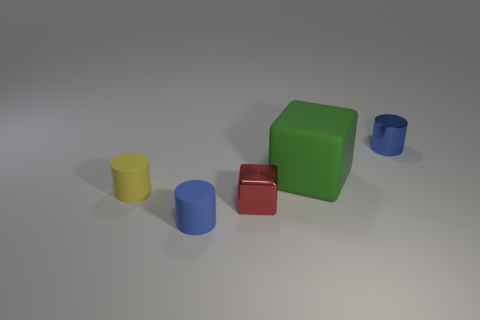Is there anything about the arrangement of the objects that stands out? The objects are arranged asymmetrically, creating a casual balance. The varied heights and distances between the shapes contribute to a dynamic yet harmonious array, which may indicate an unstaged, natural setting or a deliberately crafted composition. 